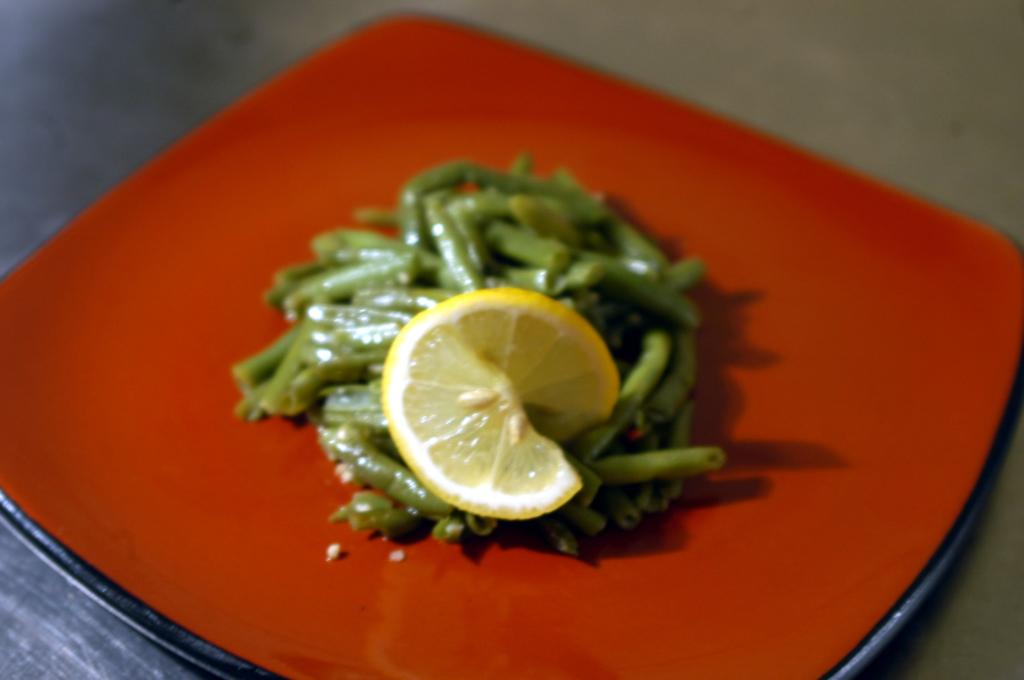What object is present on the plate in the image? The plate contains a food item. Can you describe the food item on the plate? There is a lemon slice on the plate. Where is the plate located in the image? The plate is on a platform. What type of clover is growing on the plate in the image? There is no clover present on the plate in the image; it only contains a lemon slice. Are there any trousers visible on the plate in the image? There are no trousers present on the plate in the image. 